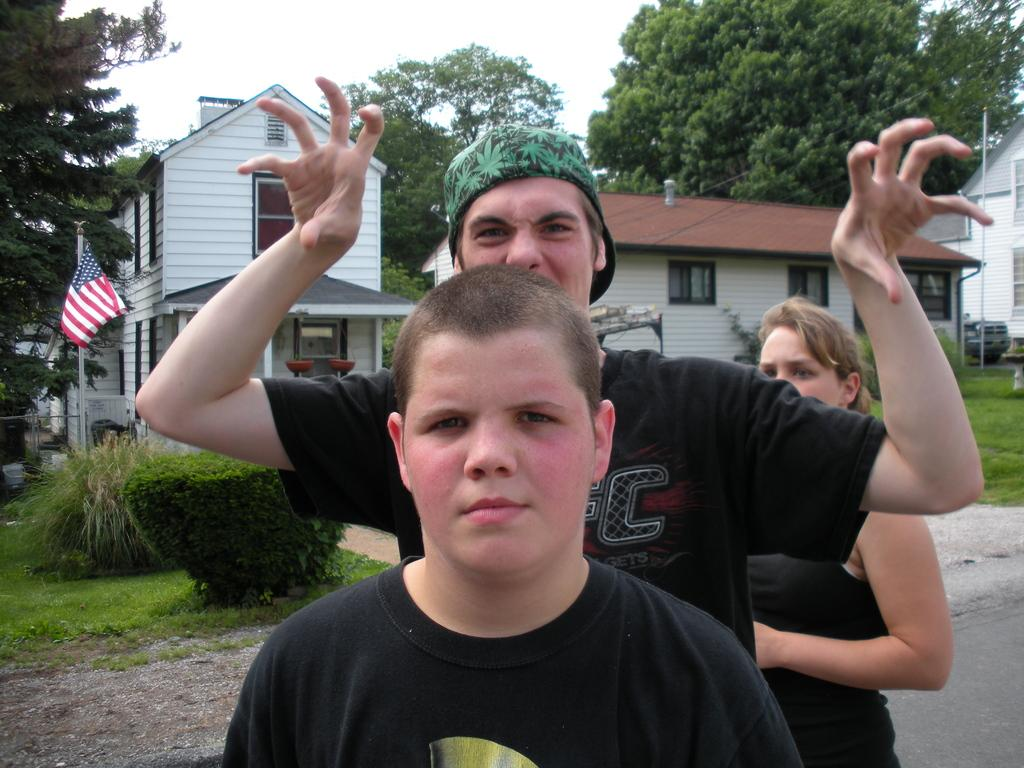How many people are present in the image? There are three people in the image. What are the people wearing? The people are wearing black dresses. What can be seen in the background of the image? There are houses, trees, plants, and grass in the background of the image. Is there any additional element to the side in the image? Yes, there is a flag to the side in the image. What is the limit of the stream visible in the image? There is no stream present in the image. 